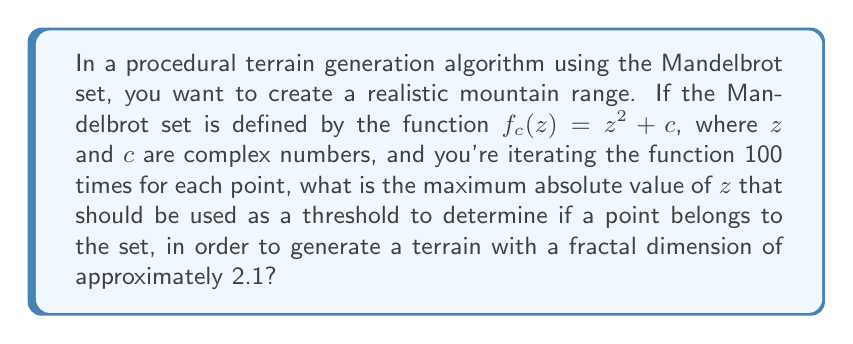Show me your answer to this math problem. To solve this problem, we'll follow these steps:

1) The fractal dimension of the Mandelbrot set's boundary is approximately 2. However, we want a terrain with a fractal dimension of 2.1, which suggests a slightly more complex boundary.

2) The Mandelbrot set is defined as the set of complex numbers $c$ for which the function $f_c(z) = z^2 + c$ does not diverge when iterated from $z = 0$.

3) In practice, we use a finite number of iterations (in this case, 100) and a threshold value to determine if a point is likely to be in the set.

4) The traditional threshold for the Mandelbrot set is 2. This is because if $|z| > 2$, the sequence will always diverge.

5) However, to increase the fractal dimension and create more complex terrain, we need to increase this threshold slightly.

6) A good approximation for the relationship between the threshold $R$ and the fractal dimension $D$ is:

   $$D \approx 2 - \frac{\log 2}{\log R}$$

7) We want $D = 2.1$, so let's solve for $R$:

   $$2.1 \approx 2 - \frac{\log 2}{\log R}$$
   $$-0.1 \approx -\frac{\log 2}{\log R}$$
   $$0.1 \approx \frac{\log 2}{\log R}$$
   $$0.1 \log R \approx \log 2$$
   $$\log R \approx 10 \log 2$$
   $$R \approx 2^{10} \approx 1024$$

8) Therefore, a threshold of approximately 1024 should be used.
Answer: 1024 